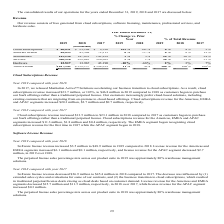According to Manhattan Associates's financial document, What is the difference in services revenue from 2018 to 2019? Based on the financial document, the answer is $30.8 million. Also, What is the increase in cloud subscription revenue in America in 2019? According to the financial document, $20.3 million. The relevant text states: "for the Americas, EMEA and APAC segments increased $20.3 million, $2.7 million and $0.7 million, respectively...." Also, What is the perpetual license sales percentages mix across product suite in 2019? approximately 80% warehouse management solutions. The document states: "rcentage mix across our product suite in 2019 was approximately 80% warehouse management solutions...." Also, can you calculate: What is the change in percentage of total revenue for cloud subscriptions in 2019 and 2018? Based on the calculation: 8%-4%, the result is 4 (percentage). This is based on the information: "iptions $ 46,831 $ 23,104 $ 9,596 103 % 141 % 8 % 4 % 2 % iptions $ 46,831 $ 23,104 $ 9,596 103 % 141 % 8 % 4 % 2 %..." The key data points involved are: 8. Also, can you calculate: What is the difference in increase in software license revenue between America and EMEA in 2019? Based on the calculation: $6.1-0.1, the result is 6 (in millions). This is based on the information: "cas and EMEA segments increased $6.1 million and $0.1 million, respectively, and license revenue for the APAC segment decreased $2.7 million, in 2019 ove nue for the Americas and EMEA segments increas..." The key data points involved are: 0.1, 6.1. Also, can you calculate: What is the difference in increase in services revenue between America and APAC in 2019? Based on the calculation: $17.8-2.7, the result is 15.1 (in millions). This is based on the information: "EMEA and APAC segments increased $20.3 million, $2.7 million and $0.7 million, respectively. EMEA and APAC segments increased $20.3 million, $2.7 million and $0.7 million, respectively...." The key data points involved are: 17.8, 2.7. 